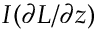<formula> <loc_0><loc_0><loc_500><loc_500>I ( { \partial L } / { \partial z } )</formula> 